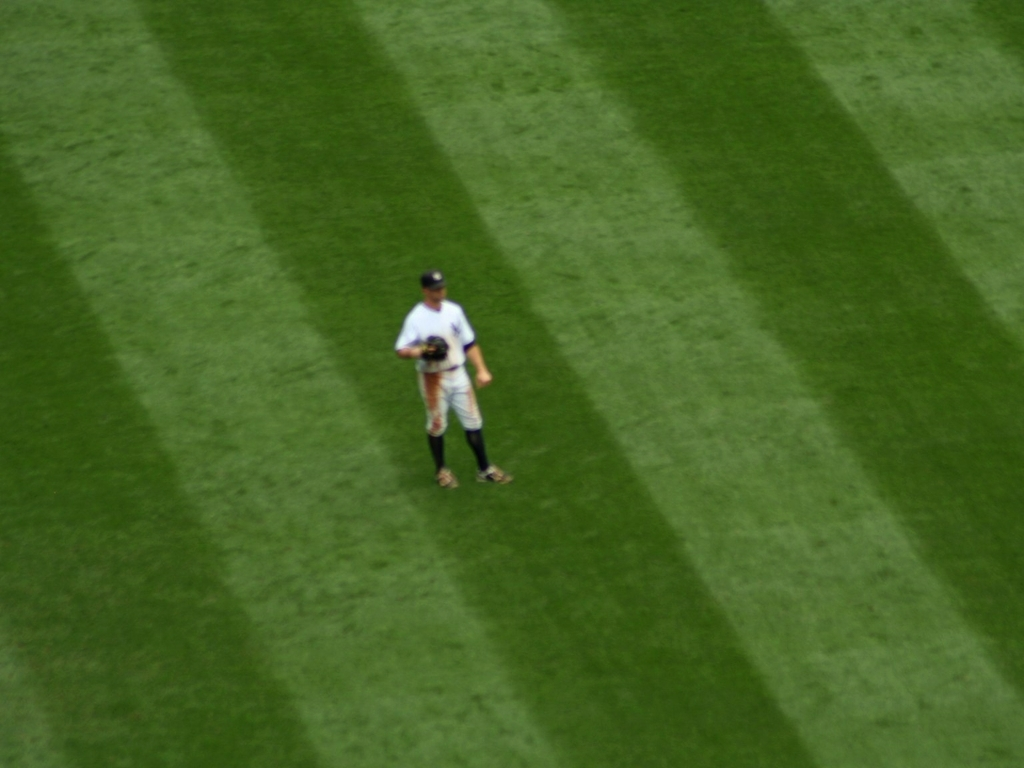What makes it difficult to distinguish the texture of the lawn and person's details?
A. High clarity
B. Blurry focus
C. Low clarity
D. Good lighting
Answer with the option's letter from the given choices directly.
 C. 